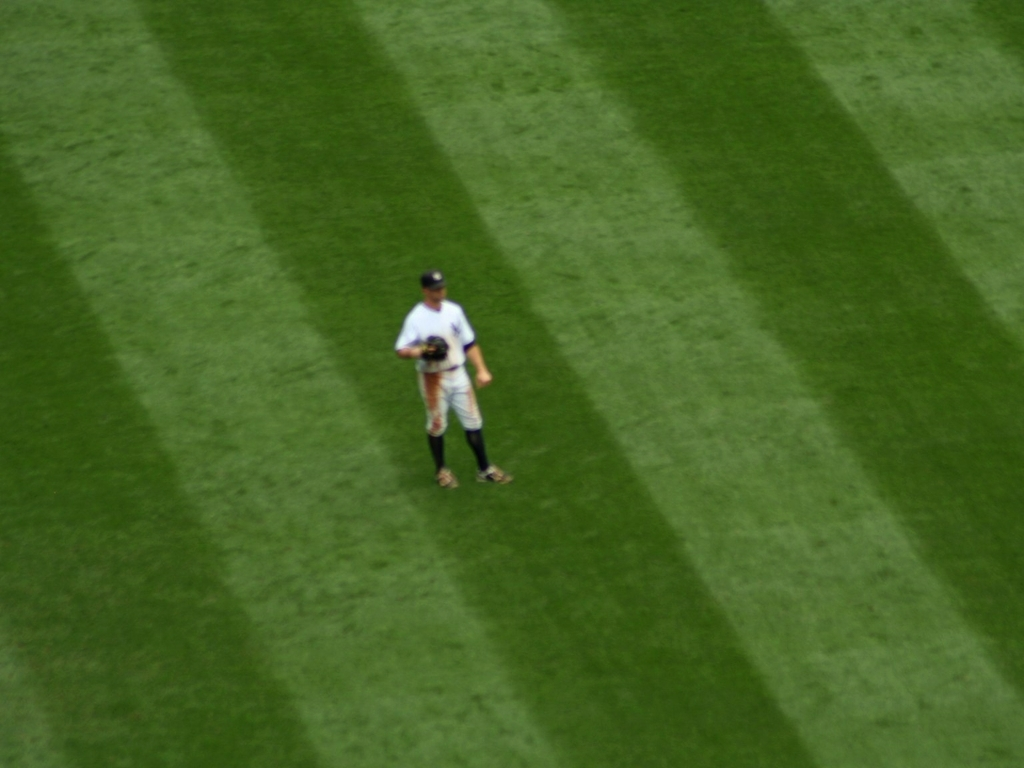What makes it difficult to distinguish the texture of the lawn and person's details?
A. High clarity
B. Blurry focus
C. Low clarity
D. Good lighting
Answer with the option's letter from the given choices directly.
 C. 